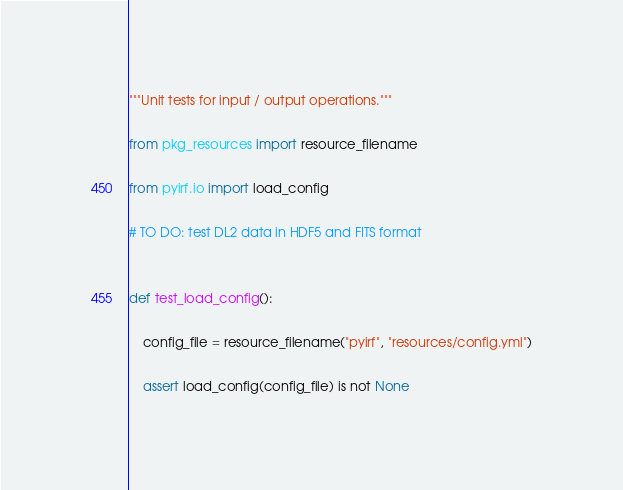<code> <loc_0><loc_0><loc_500><loc_500><_Python_>"""Unit tests for input / output operations."""

from pkg_resources import resource_filename

from pyirf.io import load_config

# TO DO: test DL2 data in HDF5 and FITS format


def test_load_config():

    config_file = resource_filename("pyirf", "resources/config.yml")

    assert load_config(config_file) is not None
</code> 